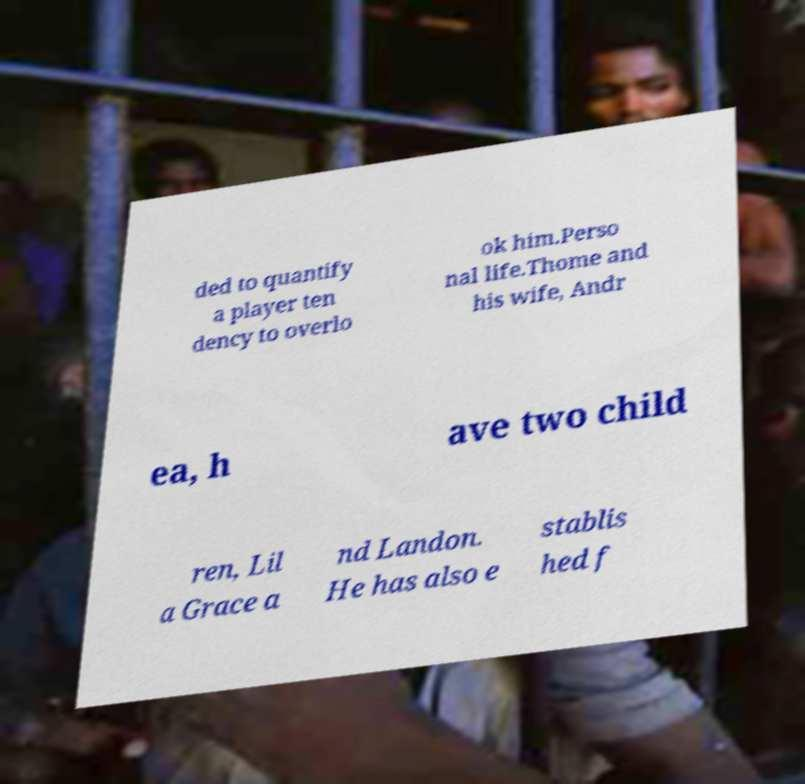For documentation purposes, I need the text within this image transcribed. Could you provide that? ded to quantify a player ten dency to overlo ok him.Perso nal life.Thome and his wife, Andr ea, h ave two child ren, Lil a Grace a nd Landon. He has also e stablis hed f 